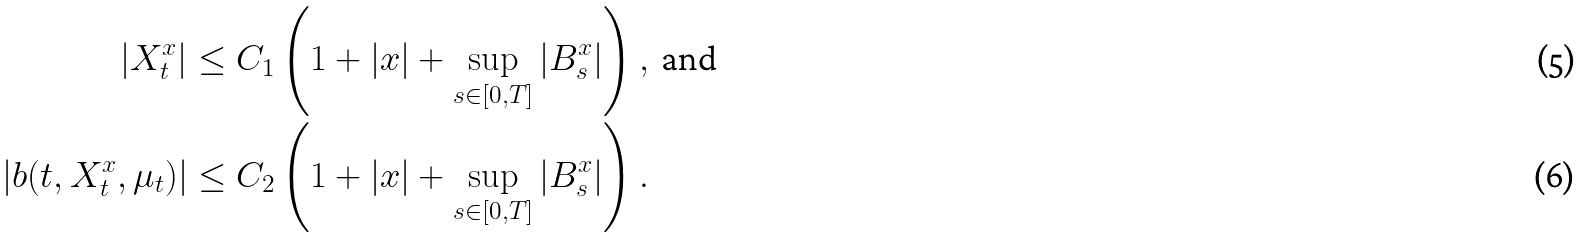Convert formula to latex. <formula><loc_0><loc_0><loc_500><loc_500>| X _ { t } ^ { x } | & \leq C _ { 1 } \left ( 1 + | x | + \sup _ { s \in [ 0 , T ] } | B _ { s } ^ { x } | \right ) , \text { and } \\ | b ( t , X _ { t } ^ { x } , \mu _ { t } ) | & \leq C _ { 2 } \left ( 1 + | x | + \sup _ { s \in [ 0 , T ] } | B _ { s } ^ { x } | \right ) .</formula> 